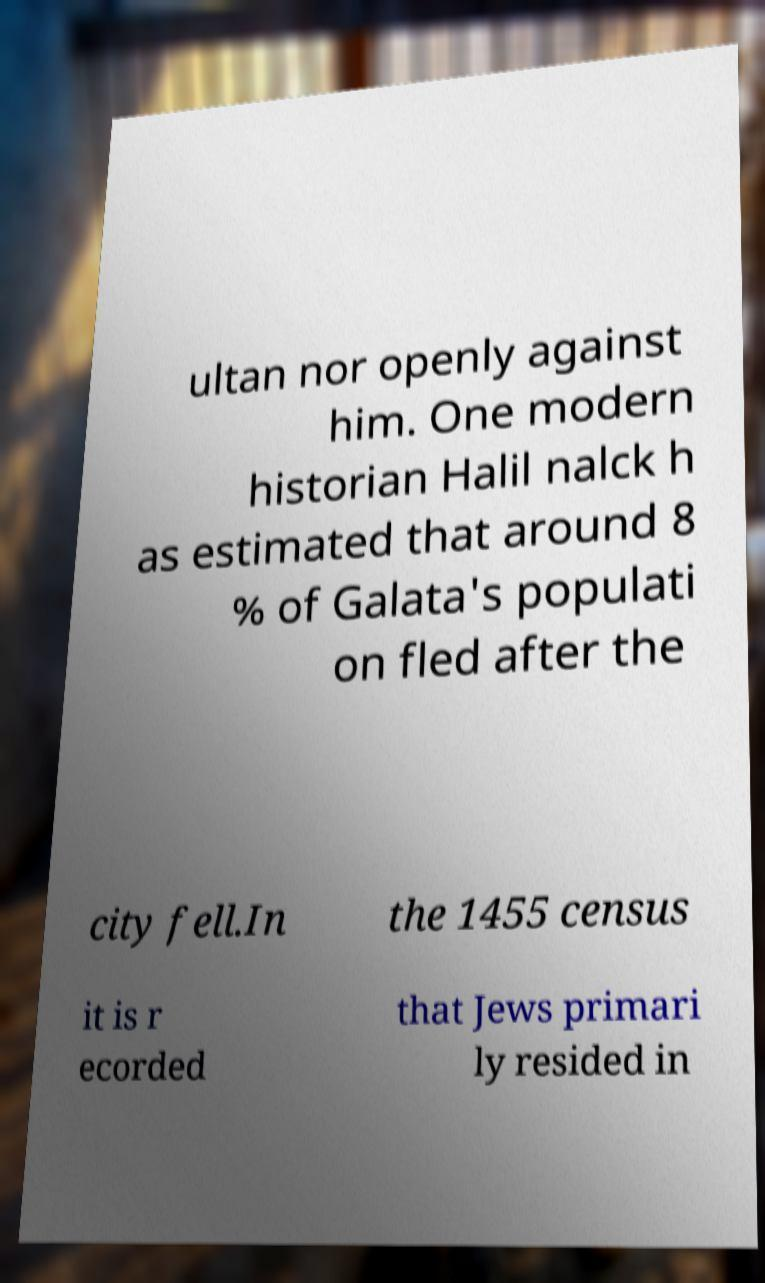Can you read and provide the text displayed in the image?This photo seems to have some interesting text. Can you extract and type it out for me? ultan nor openly against him. One modern historian Halil nalck h as estimated that around 8 % of Galata's populati on fled after the city fell.In the 1455 census it is r ecorded that Jews primari ly resided in 